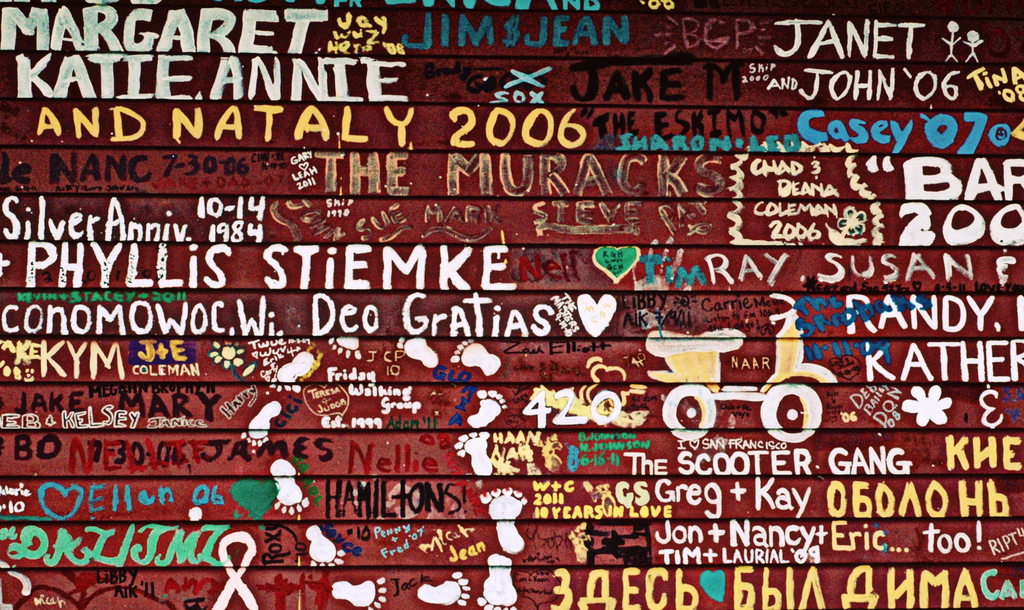What themes can you identify from the names and messages on this wall? Themes of personal milestones like anniversaries, relationships, and significant years ('1984', '2006') appear throughout the wall. There are also elements of friendship and love ('Greg + Kay'), indicating that this wall serves as a canvas for people to express affection and memorable life stages. 